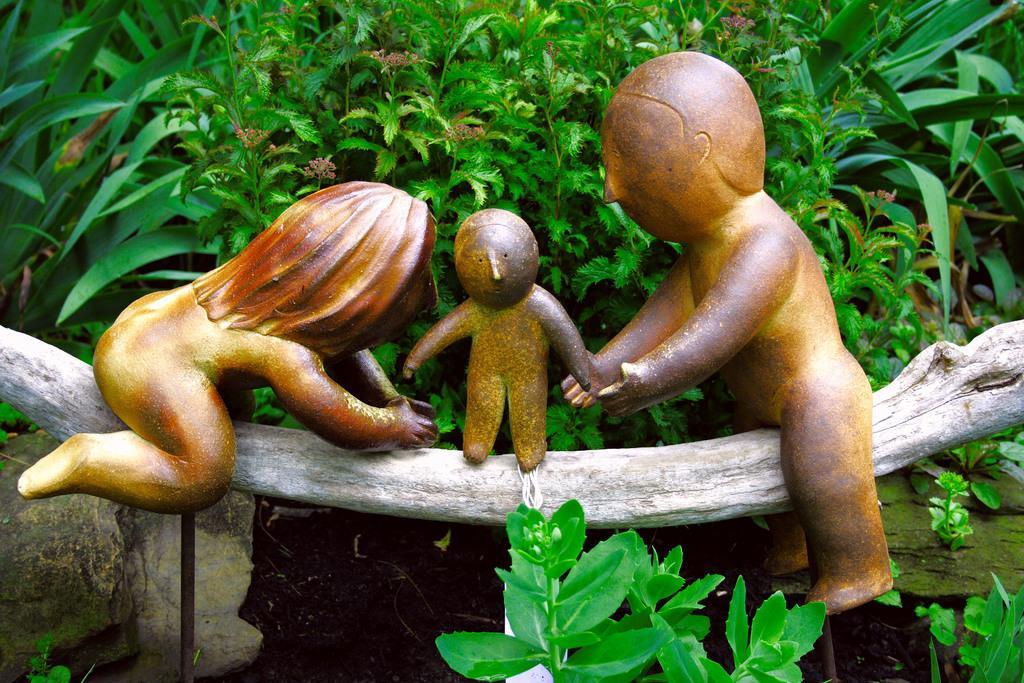Could you give a brief overview of what you see in this image? In the center of the image we can see toys placed on the log. In the background there are plants. 